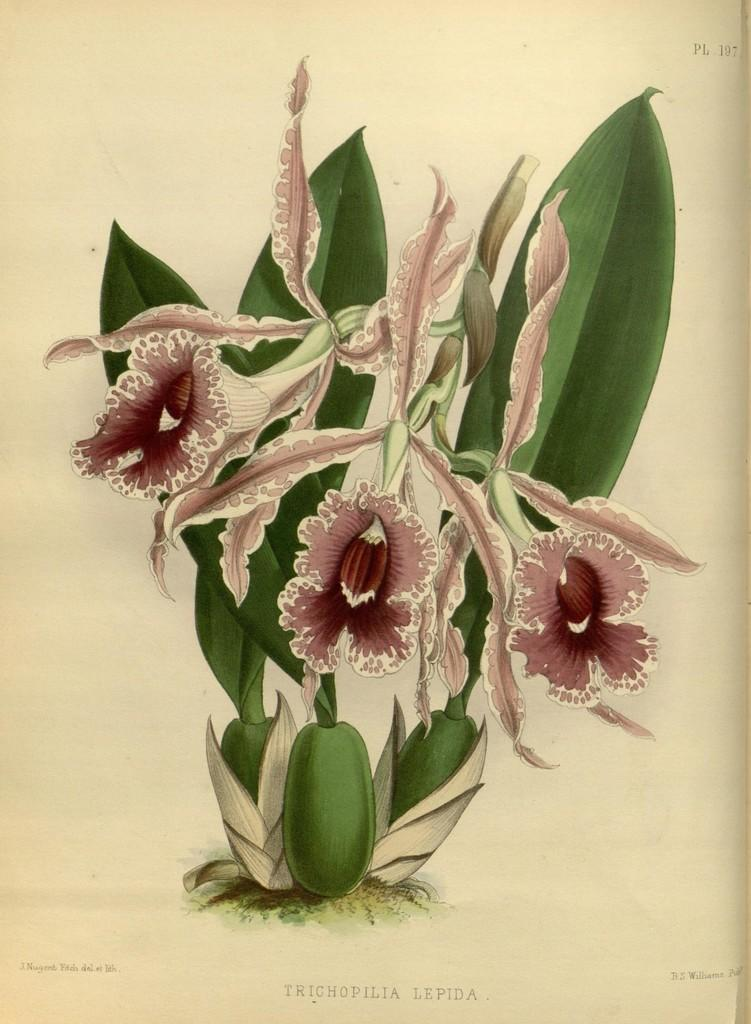What type of plant elements can be seen in the image? There are flowers, leaves, and stems in the image. Where is the text located in the image? The text is at the bottom of the image. What is present in the top right corner of the image? There are numbers in the top right corner of the image. What type of rice is being cooked in the image? There is no rice present in the image; it features flowers, leaves, and stems. How many balls are visible in the image? There are no balls present in the image. 